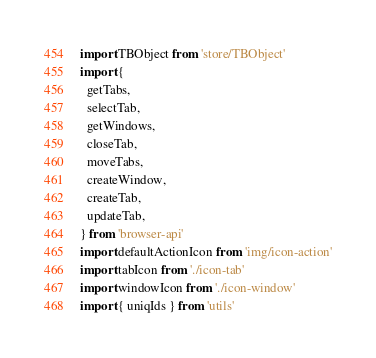<code> <loc_0><loc_0><loc_500><loc_500><_JavaScript_>import TBObject from 'store/TBObject'
import {
  getTabs,
  selectTab,
  getWindows,
  closeTab,
  moveTabs,
  createWindow,
  createTab,
  updateTab,
} from 'browser-api'
import defaultActionIcon from 'img/icon-action'
import tabIcon from './icon-tab'
import windowIcon from './icon-window'
import { uniqIds } from 'utils'
</code> 